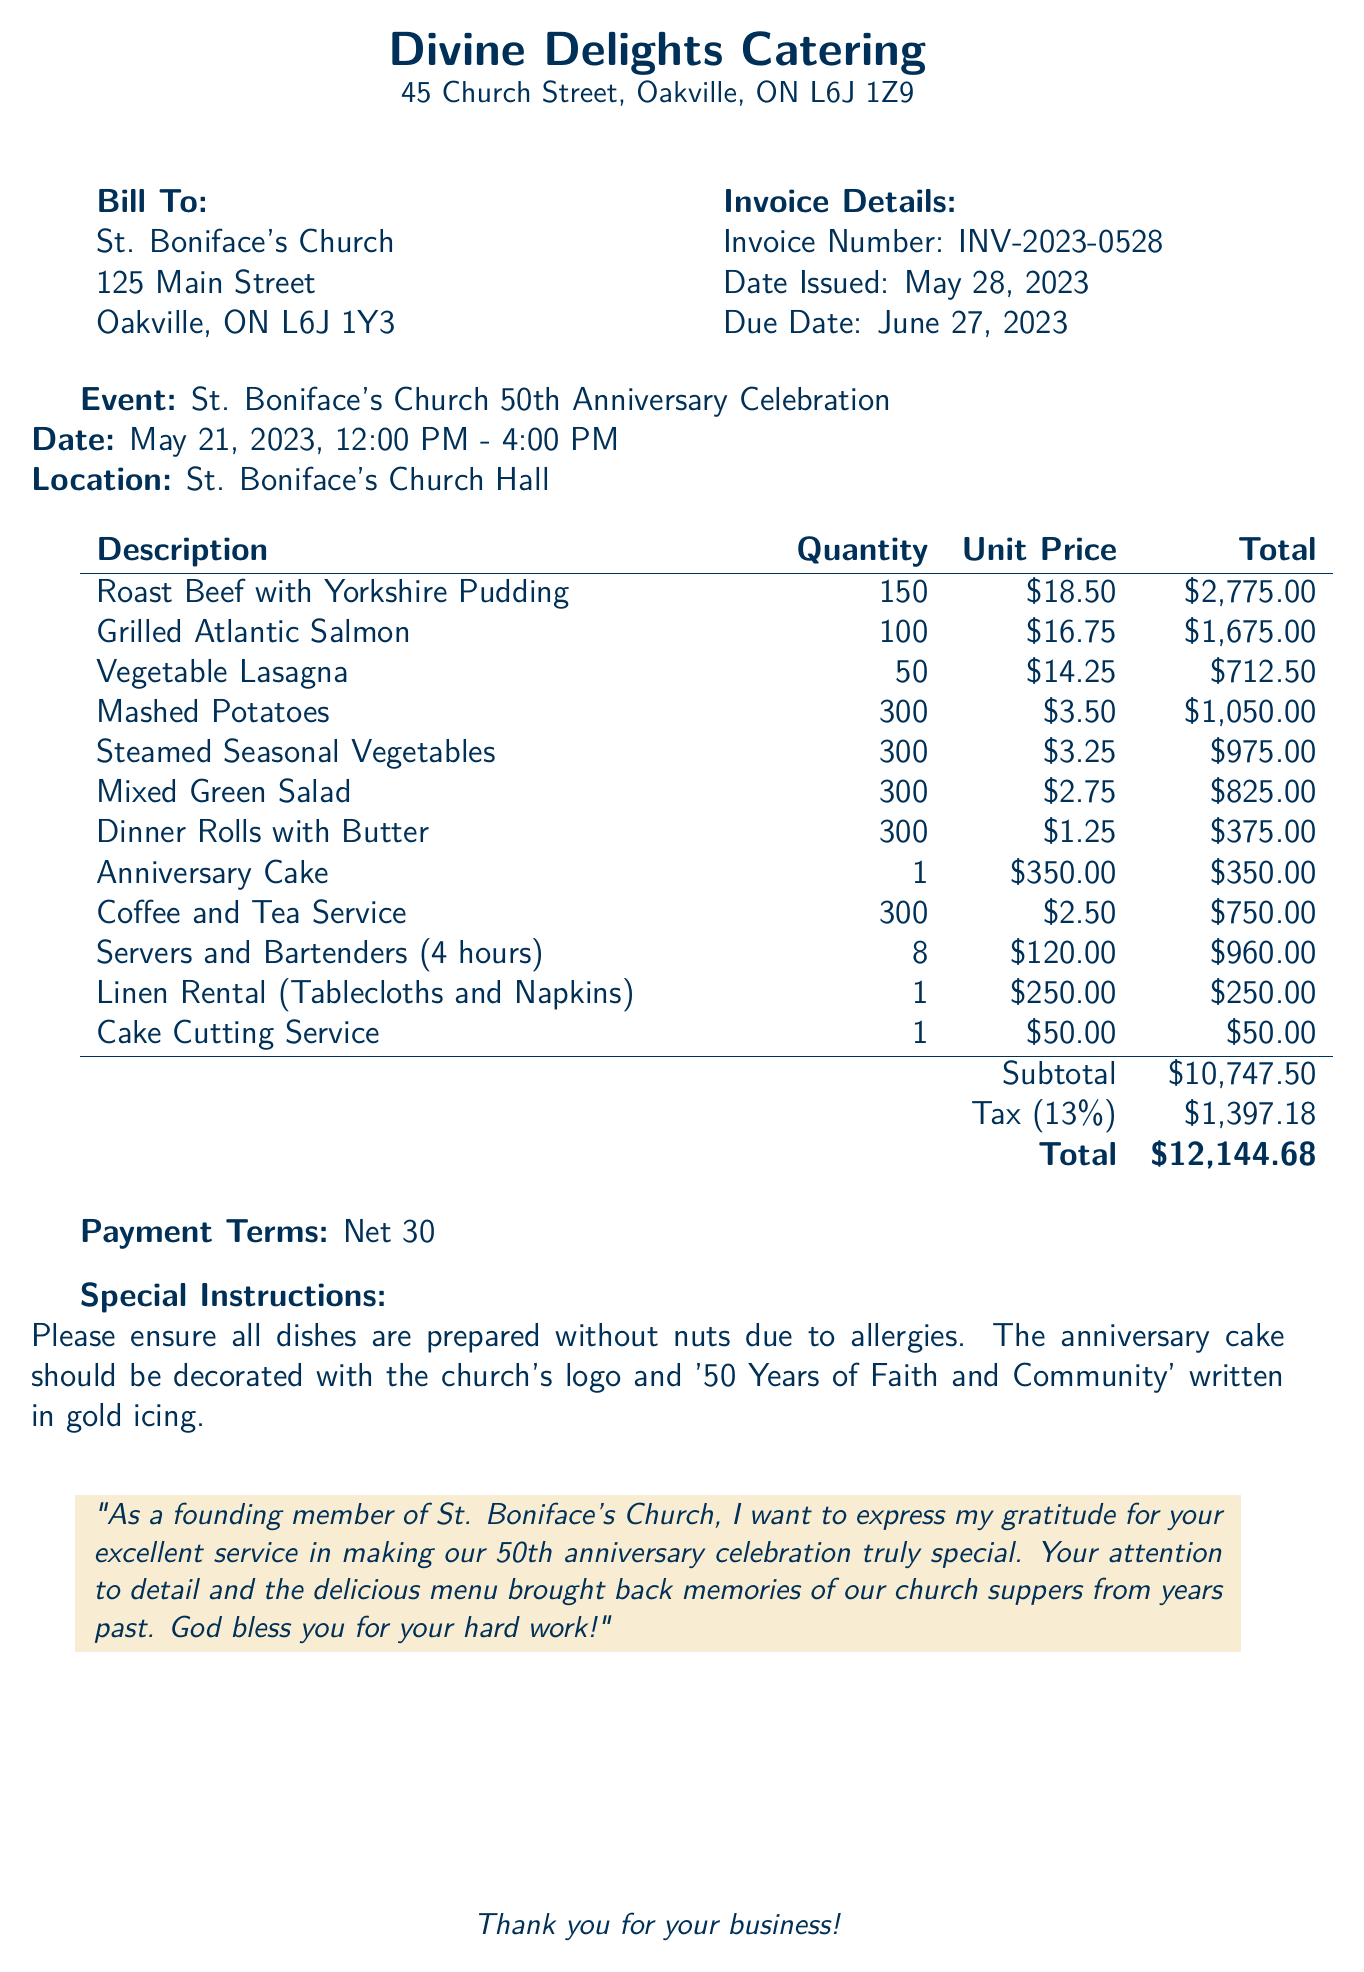What is the invoice number? The invoice number is a unique identifier for the transaction documented here.
Answer: INV-2023-0528 What is the date issued? The date issued is when the invoice was created and sent.
Answer: May 28, 2023 What is the total amount due? The total amount is the final cost after adding taxes to the subtotal.
Answer: $12,144.68 How many servings of Roast Beef were ordered? The quantity specifies how many servings of that menu item were provided.
Answer: 150 What event does this invoice pertain to? The event is the reason for the catering services being requested and documented here.
Answer: St. Boniface's Church 50th Anniversary Celebration What is the tax rate applied? The tax rate is the percentage added to the subtotal to calculate the tax amount due.
Answer: 13% What special instruction was provided? Special instructions give additional requirements for the services requested.
Answer: Please ensure all dishes are prepared without nuts due to allergies What was the quantity of Anniversary Cakes ordered? This quantity indicates how many of that specific dessert were included in the catering order.
Answer: 1 What additional service was provided along with food? The additional services are enhancements or support beyond the primary catering items.
Answer: Servers and Bartenders (4 hours) 